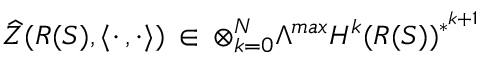<formula> <loc_0><loc_0><loc_500><loc_500>\widehat { Z } ( R ( S ) , \langle \cdot \, , \cdot \rangle ) \, \in \, \otimes _ { k = 0 } ^ { N } \Lambda ^ { \max } H ^ { k } ( R ( S ) ) ^ { * ^ { k + 1 } }</formula> 